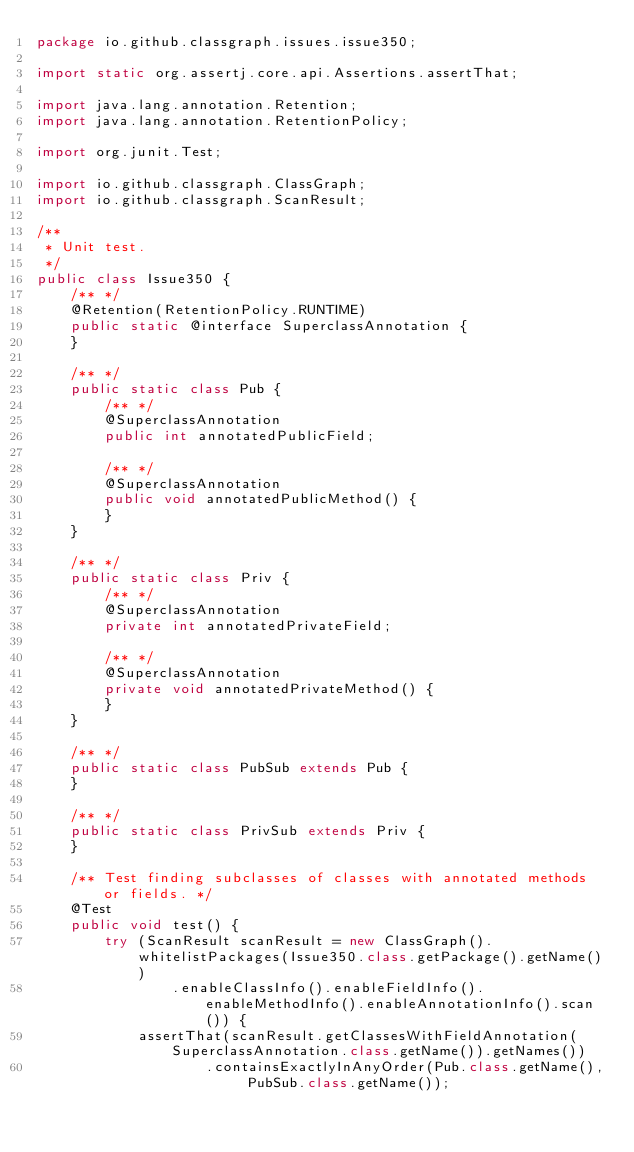Convert code to text. <code><loc_0><loc_0><loc_500><loc_500><_Java_>package io.github.classgraph.issues.issue350;

import static org.assertj.core.api.Assertions.assertThat;

import java.lang.annotation.Retention;
import java.lang.annotation.RetentionPolicy;

import org.junit.Test;

import io.github.classgraph.ClassGraph;
import io.github.classgraph.ScanResult;

/**
 * Unit test.
 */
public class Issue350 {
    /** */
    @Retention(RetentionPolicy.RUNTIME)
    public static @interface SuperclassAnnotation {
    }

    /** */
    public static class Pub {
        /** */
        @SuperclassAnnotation
        public int annotatedPublicField;

        /** */
        @SuperclassAnnotation
        public void annotatedPublicMethod() {
        }
    }

    /** */
    public static class Priv {
        /** */
        @SuperclassAnnotation
        private int annotatedPrivateField;

        /** */
        @SuperclassAnnotation
        private void annotatedPrivateMethod() {
        }
    }

    /** */
    public static class PubSub extends Pub {
    }

    /** */
    public static class PrivSub extends Priv {
    }

    /** Test finding subclasses of classes with annotated methods or fields. */
    @Test
    public void test() {
        try (ScanResult scanResult = new ClassGraph().whitelistPackages(Issue350.class.getPackage().getName())
                .enableClassInfo().enableFieldInfo().enableMethodInfo().enableAnnotationInfo().scan()) {
            assertThat(scanResult.getClassesWithFieldAnnotation(SuperclassAnnotation.class.getName()).getNames())
                    .containsExactlyInAnyOrder(Pub.class.getName(), PubSub.class.getName());</code> 